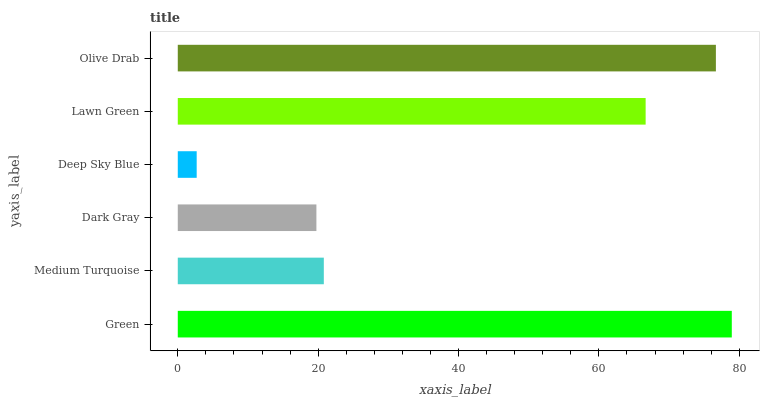Is Deep Sky Blue the minimum?
Answer yes or no. Yes. Is Green the maximum?
Answer yes or no. Yes. Is Medium Turquoise the minimum?
Answer yes or no. No. Is Medium Turquoise the maximum?
Answer yes or no. No. Is Green greater than Medium Turquoise?
Answer yes or no. Yes. Is Medium Turquoise less than Green?
Answer yes or no. Yes. Is Medium Turquoise greater than Green?
Answer yes or no. No. Is Green less than Medium Turquoise?
Answer yes or no. No. Is Lawn Green the high median?
Answer yes or no. Yes. Is Medium Turquoise the low median?
Answer yes or no. Yes. Is Olive Drab the high median?
Answer yes or no. No. Is Olive Drab the low median?
Answer yes or no. No. 